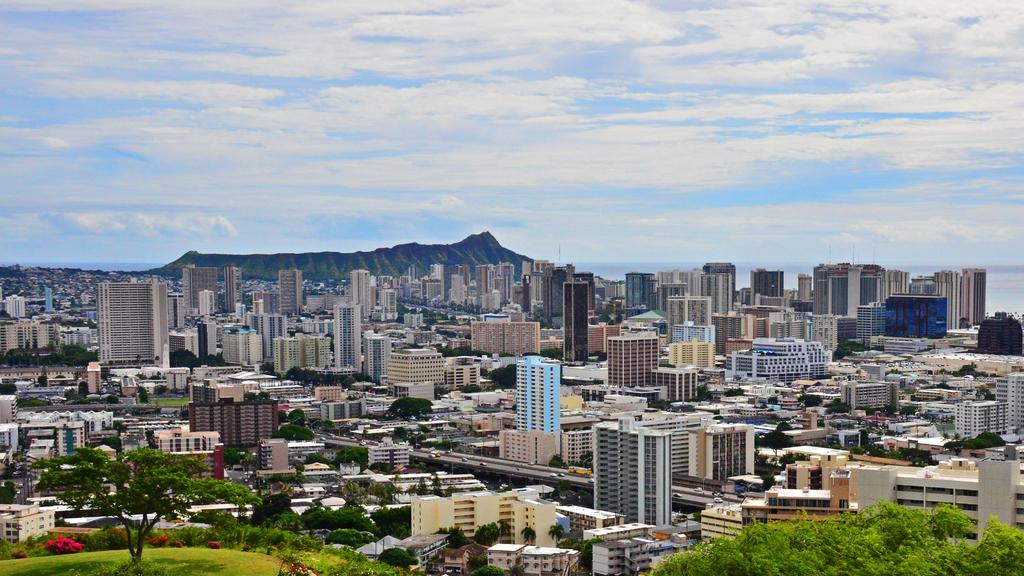What is the image is an overview of what type of location? The image is an overview of a city. What structures can be seen in the image? There are many buildings in the image. Are there any natural elements present in the image? Yes, trees are present in the image. What geographical feature can be seen in the image? There is a mountain visible in the image. What is the condition of the sky in the image? The sky is full of clouds. Where is the jail located in the image? There is no jail present in the image. What type of sugar is being used to sweeten the mountain in the image? There is no sugar or sweetening involved in the image; it is a natural geographical feature. 